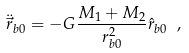<formula> <loc_0><loc_0><loc_500><loc_500>\ddot { \vec { r } } _ { b 0 } = - G \frac { M _ { 1 } + M _ { 2 } } { r _ { b 0 } ^ { 2 } } \hat { r } _ { b 0 } \ ,</formula> 